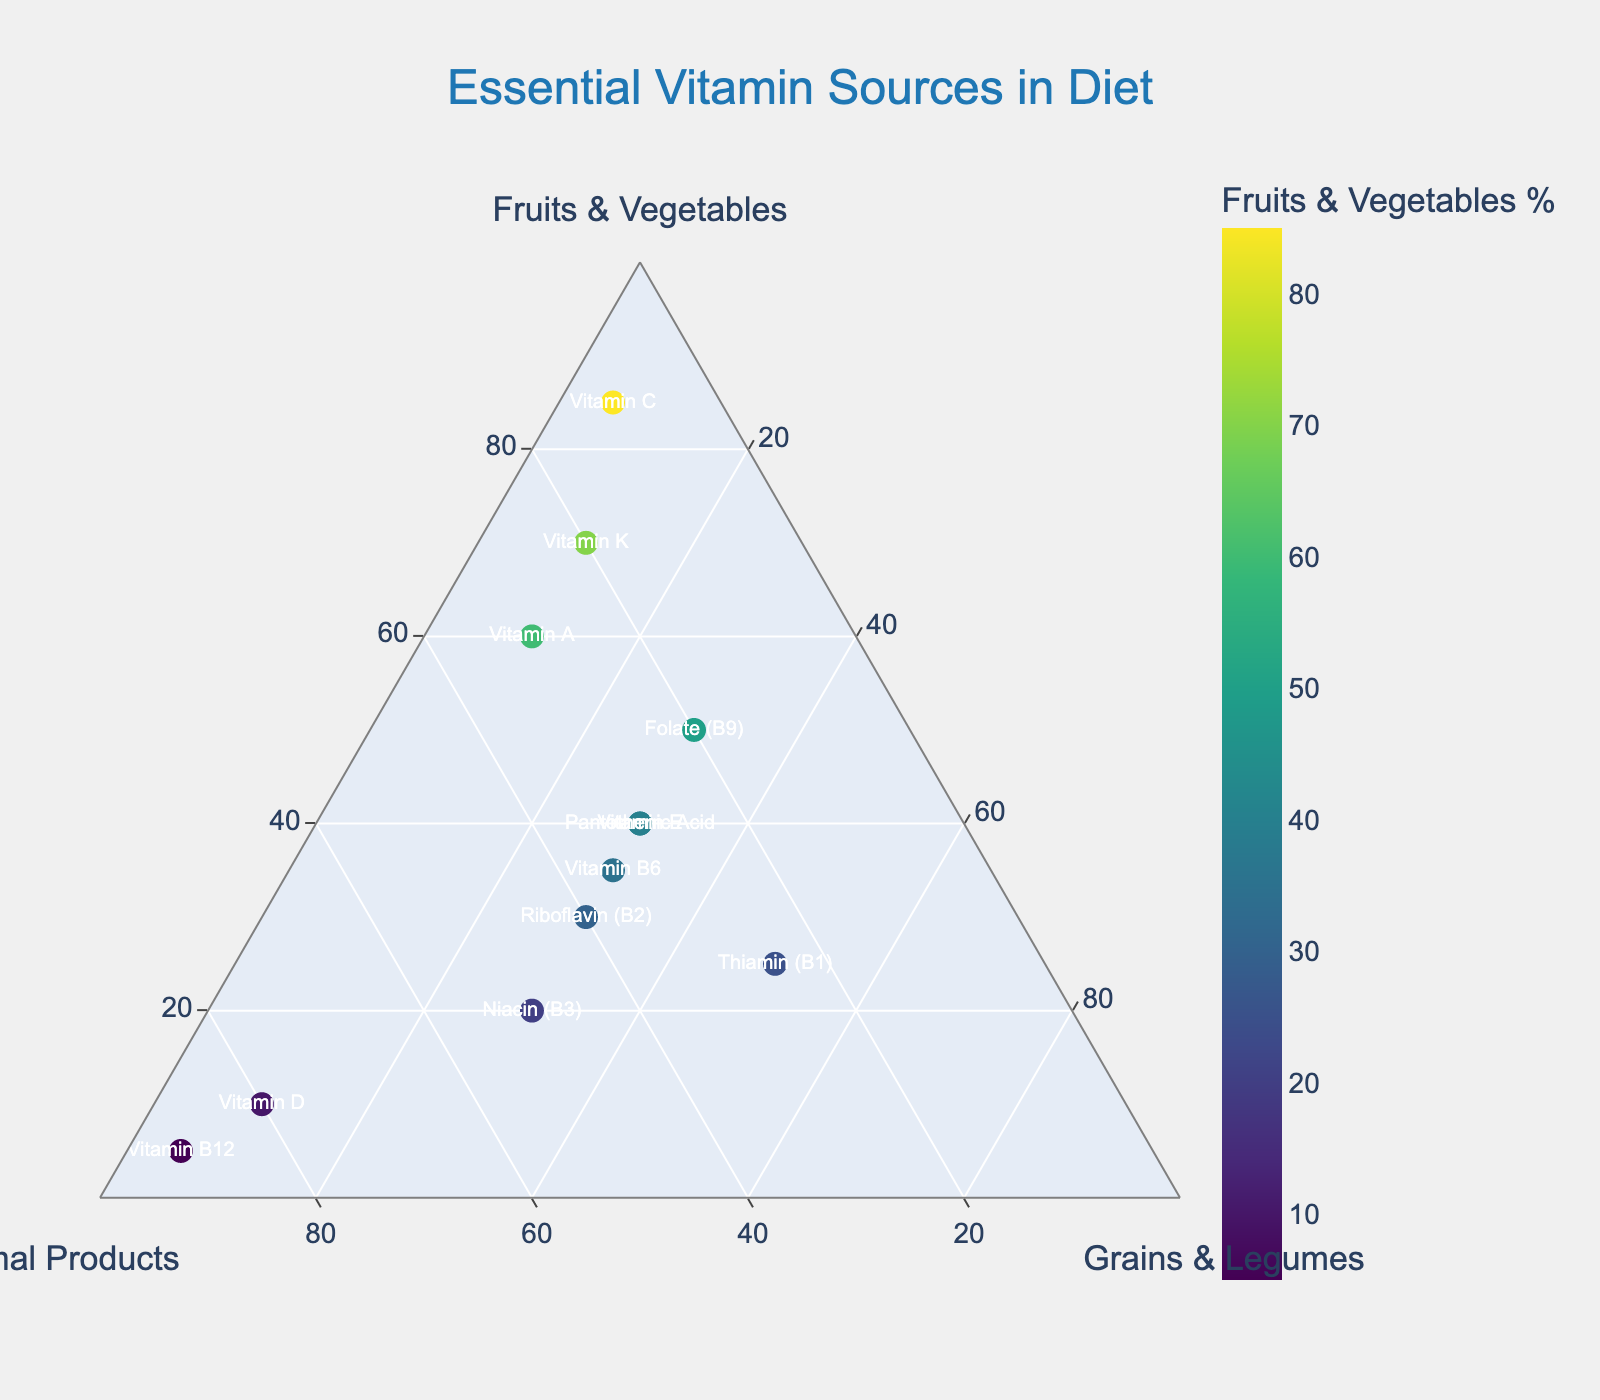What is the title of the plot? The title of the plot is displayed prominently at the top of the figure. It reads "Essential Vitamin Sources in Diet".
Answer: Essential Vitamin Sources in Diet Which axis represents the percentage of Animal Products? The axis representing Animal Products is labeled "Animal Products" with a minimum value indication and is found on one side of the ternary plot.
Answer: Animal Products What color scale is used to represent the percentage of Fruits and Vegetables? The color of the markers varies according to the Fruits & Vegetables percentage, and the color scheme is labeled 'Viridis'.
Answer: Viridis What is the source of Vitamin B12 intake with the highest percentage? Locate Vitamin B12 on the plot. The hover template shows that it is mostly from Animal Products, at 90%.
Answer: Animal Products Which vitamin has the highest proportion from Grains and Legumes? Scan for the vitamin with the highest value under "Grains & Legumes". Thiamin (B1) has 50%, highest among the listed vitamins.
Answer: Thiamin (B1) Can you identify a vitamin source that has an equal percentage from all three food categories? Look for a vitamin where Fruits & Vegetables, Animal Products, and Grains & Legumes values are equal. There is none with equal percentages.
Answer: None Which vitamin has a substantial contribution from both Fruits & Vegetables and Animal Products, but less from Grains & Legumes? Analyze the closer distribution between Fruits & Vegetables and Animal Products, then cross-check against Grains & Legumes. Vitamin K fits this, with 70% Fruits & Vegetables and 20% Animal Products.
Answer: Vitamin K Which vitamin has the most diverse source distribution? "Most diverse" indicates the least disparity among the three sources. Pantothenic Acid (40% Fruits & Vegetables, 30% Animal Products, 30% Grains & Legumes) is balanced.
Answer: Pantothenic Acid What is the combined percentage of Fruits & Vegetables for Vitamins A and C? Sum the percentages of Fruits & Vegetables for Vitamin A (60%) and Vitamin C (85%), resulting in 60 + 85 = 145.
Answer: 145% Compare the source composition of Vitamin D and Vitamin E. Which one has a higher Animal Products percentage? Evaluate the Animal Products percentage for Vitamin D (80%) and Vitamin E (30%). Vitamin D has a higher percentage.
Answer: Vitamin D 